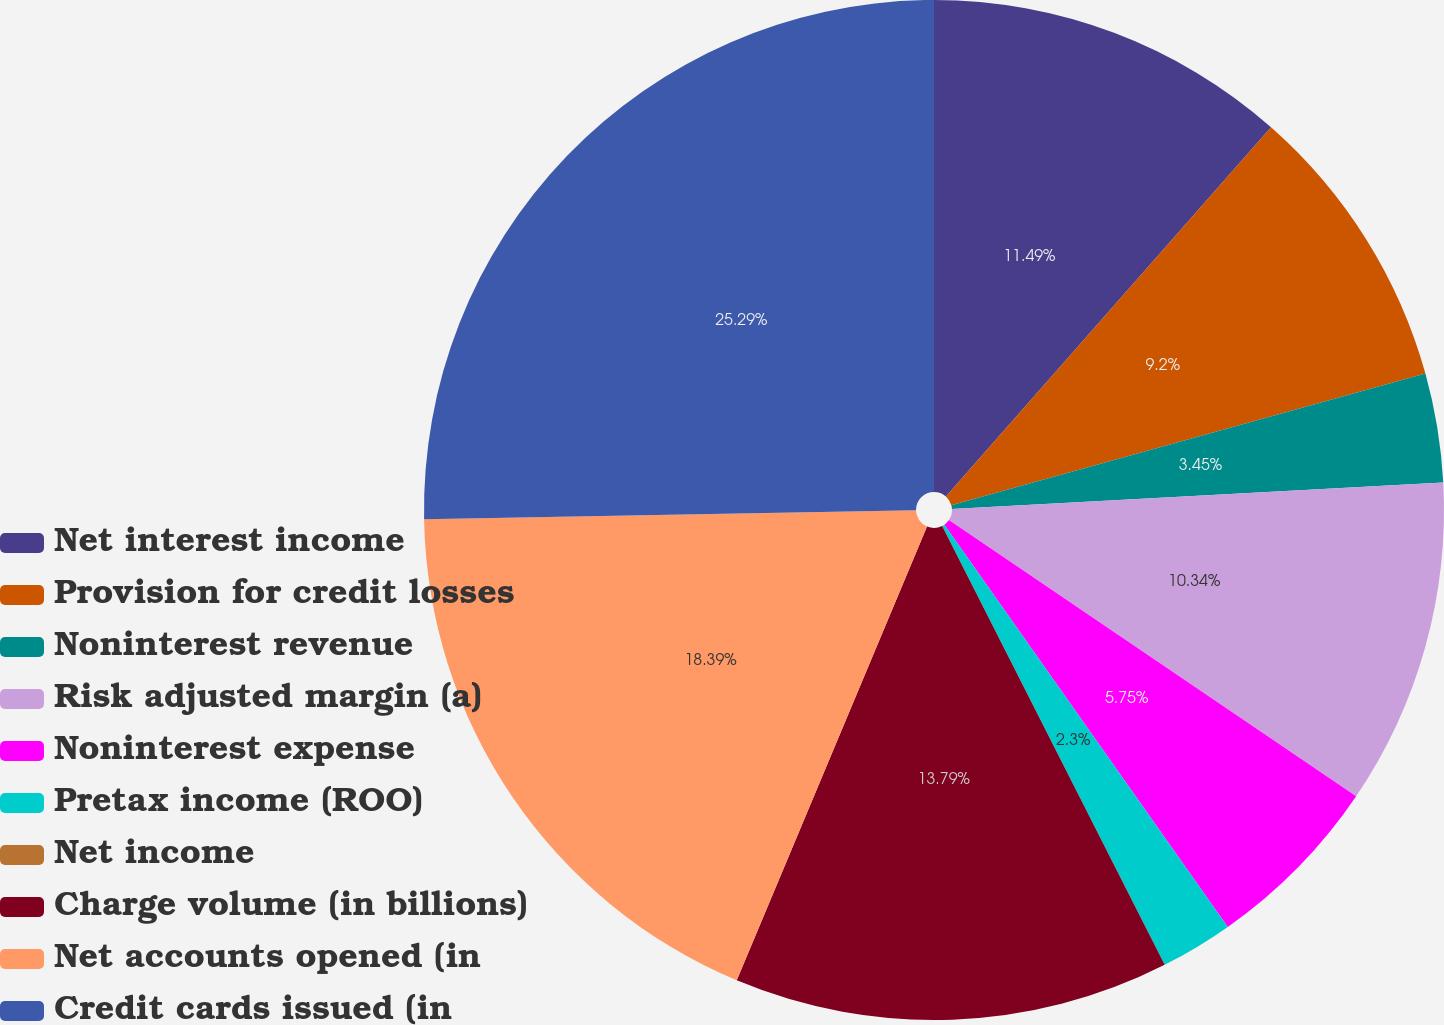Convert chart to OTSL. <chart><loc_0><loc_0><loc_500><loc_500><pie_chart><fcel>Net interest income<fcel>Provision for credit losses<fcel>Noninterest revenue<fcel>Risk adjusted margin (a)<fcel>Noninterest expense<fcel>Pretax income (ROO)<fcel>Net income<fcel>Charge volume (in billions)<fcel>Net accounts opened (in<fcel>Credit cards issued (in<nl><fcel>11.49%<fcel>9.2%<fcel>3.45%<fcel>10.34%<fcel>5.75%<fcel>2.3%<fcel>0.0%<fcel>13.79%<fcel>18.39%<fcel>25.29%<nl></chart> 